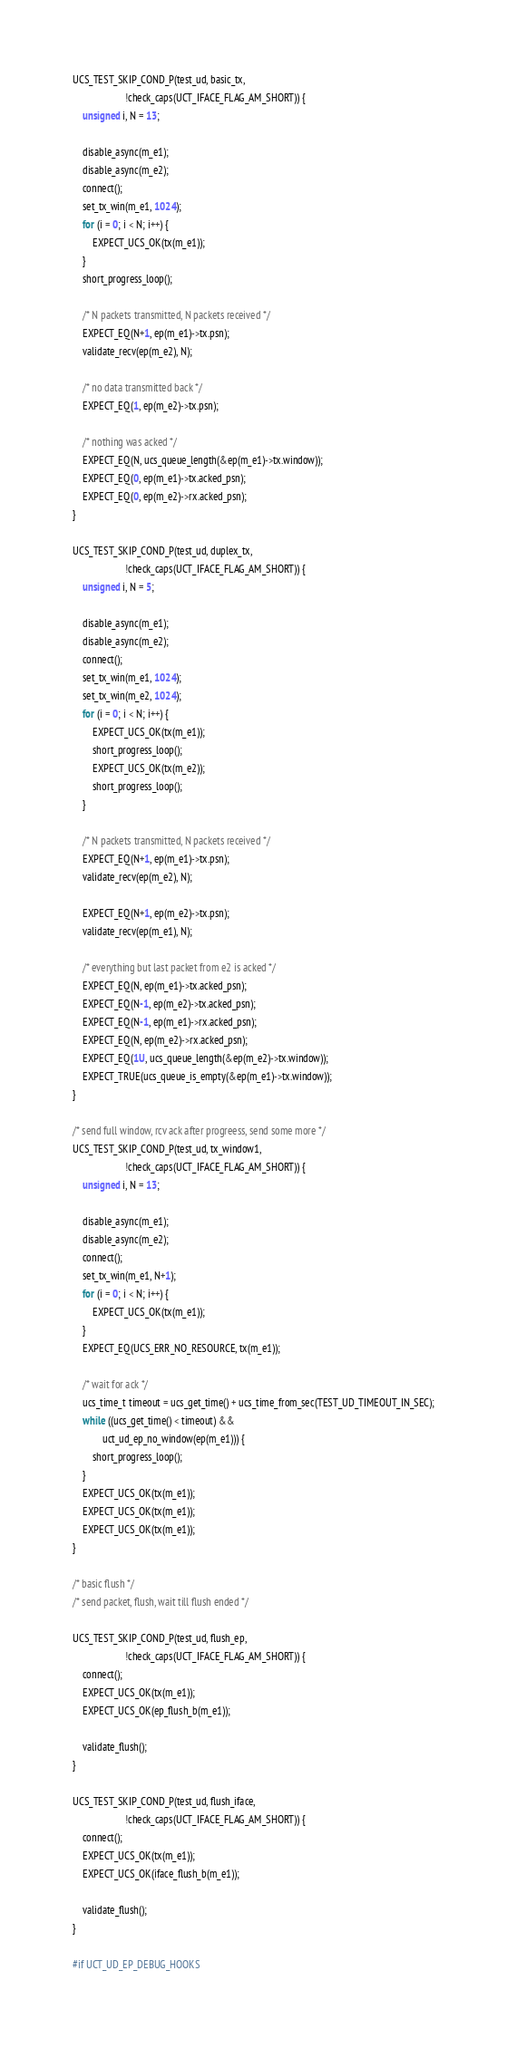Convert code to text. <code><loc_0><loc_0><loc_500><loc_500><_C++_>UCS_TEST_SKIP_COND_P(test_ud, basic_tx,
                     !check_caps(UCT_IFACE_FLAG_AM_SHORT)) {
    unsigned i, N = 13;

    disable_async(m_e1);
    disable_async(m_e2);
    connect();
    set_tx_win(m_e1, 1024);
    for (i = 0; i < N; i++) {
        EXPECT_UCS_OK(tx(m_e1));
    }
    short_progress_loop();

    /* N packets transmitted, N packets received */
    EXPECT_EQ(N+1, ep(m_e1)->tx.psn);
    validate_recv(ep(m_e2), N);

    /* no data transmitted back */
    EXPECT_EQ(1, ep(m_e2)->tx.psn);

    /* nothing was acked */
    EXPECT_EQ(N, ucs_queue_length(&ep(m_e1)->tx.window));
    EXPECT_EQ(0, ep(m_e1)->tx.acked_psn);
    EXPECT_EQ(0, ep(m_e2)->rx.acked_psn);
}

UCS_TEST_SKIP_COND_P(test_ud, duplex_tx,
                     !check_caps(UCT_IFACE_FLAG_AM_SHORT)) {
    unsigned i, N = 5;

    disable_async(m_e1);
    disable_async(m_e2);
    connect();
    set_tx_win(m_e1, 1024);
    set_tx_win(m_e2, 1024);
    for (i = 0; i < N; i++) {
        EXPECT_UCS_OK(tx(m_e1));
        short_progress_loop();
        EXPECT_UCS_OK(tx(m_e2));
        short_progress_loop();
    }

    /* N packets transmitted, N packets received */
    EXPECT_EQ(N+1, ep(m_e1)->tx.psn);
    validate_recv(ep(m_e2), N);

    EXPECT_EQ(N+1, ep(m_e2)->tx.psn);
    validate_recv(ep(m_e1), N);

    /* everything but last packet from e2 is acked */
    EXPECT_EQ(N, ep(m_e1)->tx.acked_psn);
    EXPECT_EQ(N-1, ep(m_e2)->tx.acked_psn);
    EXPECT_EQ(N-1, ep(m_e1)->rx.acked_psn);
    EXPECT_EQ(N, ep(m_e2)->rx.acked_psn);
    EXPECT_EQ(1U, ucs_queue_length(&ep(m_e2)->tx.window));
    EXPECT_TRUE(ucs_queue_is_empty(&ep(m_e1)->tx.window));
}

/* send full window, rcv ack after progreess, send some more */
UCS_TEST_SKIP_COND_P(test_ud, tx_window1,
                     !check_caps(UCT_IFACE_FLAG_AM_SHORT)) {
    unsigned i, N = 13;

    disable_async(m_e1);
    disable_async(m_e2);
    connect();
    set_tx_win(m_e1, N+1);
    for (i = 0; i < N; i++) {
        EXPECT_UCS_OK(tx(m_e1));
    }
    EXPECT_EQ(UCS_ERR_NO_RESOURCE, tx(m_e1));

    /* wait for ack */
    ucs_time_t timeout = ucs_get_time() + ucs_time_from_sec(TEST_UD_TIMEOUT_IN_SEC);
    while ((ucs_get_time() < timeout) &&
            uct_ud_ep_no_window(ep(m_e1))) {
        short_progress_loop();
    }
    EXPECT_UCS_OK(tx(m_e1));
    EXPECT_UCS_OK(tx(m_e1));
    EXPECT_UCS_OK(tx(m_e1));
}

/* basic flush */
/* send packet, flush, wait till flush ended */

UCS_TEST_SKIP_COND_P(test_ud, flush_ep,
                     !check_caps(UCT_IFACE_FLAG_AM_SHORT)) {
    connect();
    EXPECT_UCS_OK(tx(m_e1));
    EXPECT_UCS_OK(ep_flush_b(m_e1));

    validate_flush();
}

UCS_TEST_SKIP_COND_P(test_ud, flush_iface,
                     !check_caps(UCT_IFACE_FLAG_AM_SHORT)) {
    connect();
    EXPECT_UCS_OK(tx(m_e1));
    EXPECT_UCS_OK(iface_flush_b(m_e1));

    validate_flush();
}

#if UCT_UD_EP_DEBUG_HOOKS
</code> 